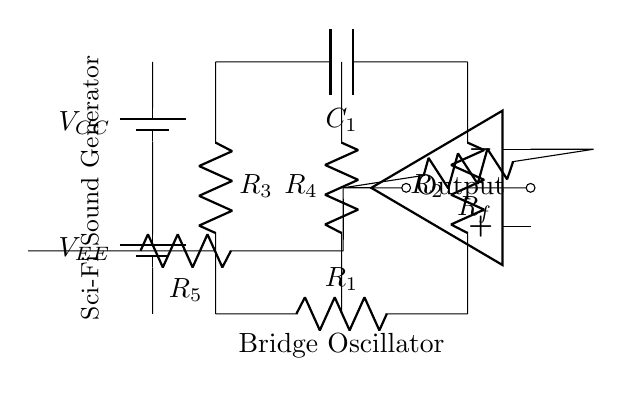What are the resistors labeled in this circuit? The circuit includes four resistors labeled R1, R2, R3, and R4, which are indicated on the circuit diagram.
Answer: R1, R2, R3, R4 What component is responsible for feedback in the oscillator circuit? The feedback in the oscillator circuit is provided by resistor R5, which connects the output of the op-amp back to the input side.
Answer: R5 How many capacitors are present in the circuit diagram? There is one capacitor labeled C1 in the circuit, as seen in the diagram between R2 and R3.
Answer: 1 What type of circuit is represented in the diagram? This circuit is a bridge oscillator, which is characterized by its specific configuration of resistors and capacitors designed to generate oscillations.
Answer: Bridge oscillator Which components are connected in parallel? R4 and the combination of R1, R2, and C1 are connected in parallel, allowing for differences in impedance that contribute to oscillation.
Answer: R4, R1, R2, C1 What is the power supply voltage indicated in the circuit? The circuit shows two power supplies, labeled VCC at the top and VEE at the bottom; their values are not specified on the diagram but imply a dual supply operation.
Answer: VCC, VEE What is the role of the op-amp in this circuit? The operational amplifier (op-amp) serves to amplify the output signal generated by the oscillating circuit, effectively controlling the gain of the oscillation.
Answer: Amplifier 